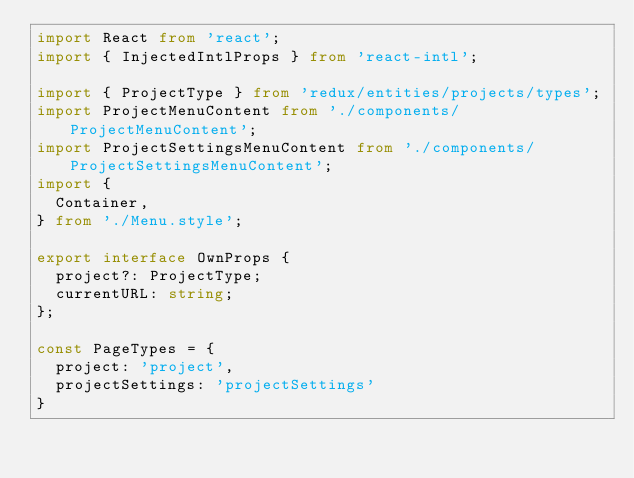<code> <loc_0><loc_0><loc_500><loc_500><_TypeScript_>import React from 'react';
import { InjectedIntlProps } from 'react-intl';

import { ProjectType } from 'redux/entities/projects/types';
import ProjectMenuContent from './components/ProjectMenuContent';
import ProjectSettingsMenuContent from './components/ProjectSettingsMenuContent';
import {
  Container,
} from './Menu.style';

export interface OwnProps {
  project?: ProjectType;
  currentURL: string;
};

const PageTypes = {
  project: 'project',
  projectSettings: 'projectSettings'
}
</code> 